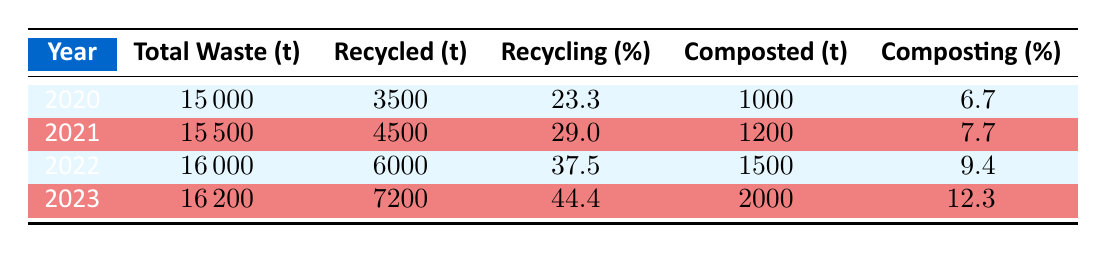What was the total waste collected in 2021? According to the table, the total waste collected in 2021 is listed in the second row, which shows a value of 15,500 tons.
Answer: 15,500 tons What is the recycling rate for the year 2022? The recycling rate for the year 2022 is in the third row of the table, which indicates a recycling rate of 37.5%.
Answer: 37.5% In which year was the composting rate highest? Looking at the composting rate percentages in the table, the highest value is 12.3% for the year 2023, which is shown in the last row.
Answer: 2023 What was the increase in total waste collected from 2020 to 2023? To find the increase, we subtract the total waste collected in 2020 (15,000 tons) from the total waste collected in 2023 (16,200 tons). Thus, 16,200 - 15,000 equals 1,200 tons.
Answer: 1,200 tons Did the recycling rate increase every year from 2020 to 2023? By examining the recycling rates listed for each year, they show an increase: 23.3% in 2020, 29% in 2021, 37.5% in 2022, and 44.4% in 2023. Therefore, it can be concluded that the recycling rate did indeed increase each year.
Answer: Yes What is the average amount of recycled waste collected from 2020 to 2023? We calculate the average by first adding up the recycled waste amounts: 3,500 + 4,500 + 6,000 + 7,200 equals 21,200 tons. Then, divide by the total number of years, which is 4, yielding an average of 21,200 divided by 4 equals 5,300 tons.
Answer: 5,300 tons How much composted waste was collected in 2022 compared to 2021? The table shows that 1,500 tons were composted in 2022, while 1,200 tons were composted in 2021. The difference is found by subtracting these figures: 1,500 - 1,200 equals 300 tons more composted in 2022.
Answer: 300 tons more What percentage of total waste was recycled in the year 2020? The table specifies that in 2020, the recycling rate was 23.3%. This percentage represents the proportion of total waste that was recycled that year.
Answer: 23.3% Is it true that more waste was composted than recycled in 2020? Based on the table, 3,500 tons of waste were recycled compared to 1,000 tons that were composted in 2020. This indicates that more waste was recycled than composted that year.
Answer: No 